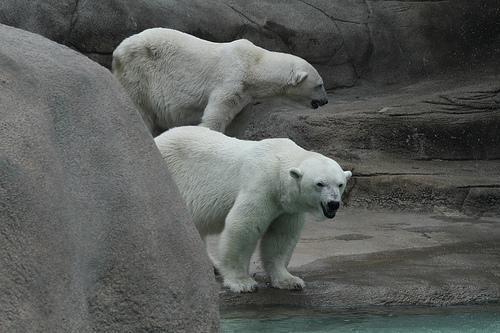How many bears are in the pen?
Give a very brief answer. 2. 